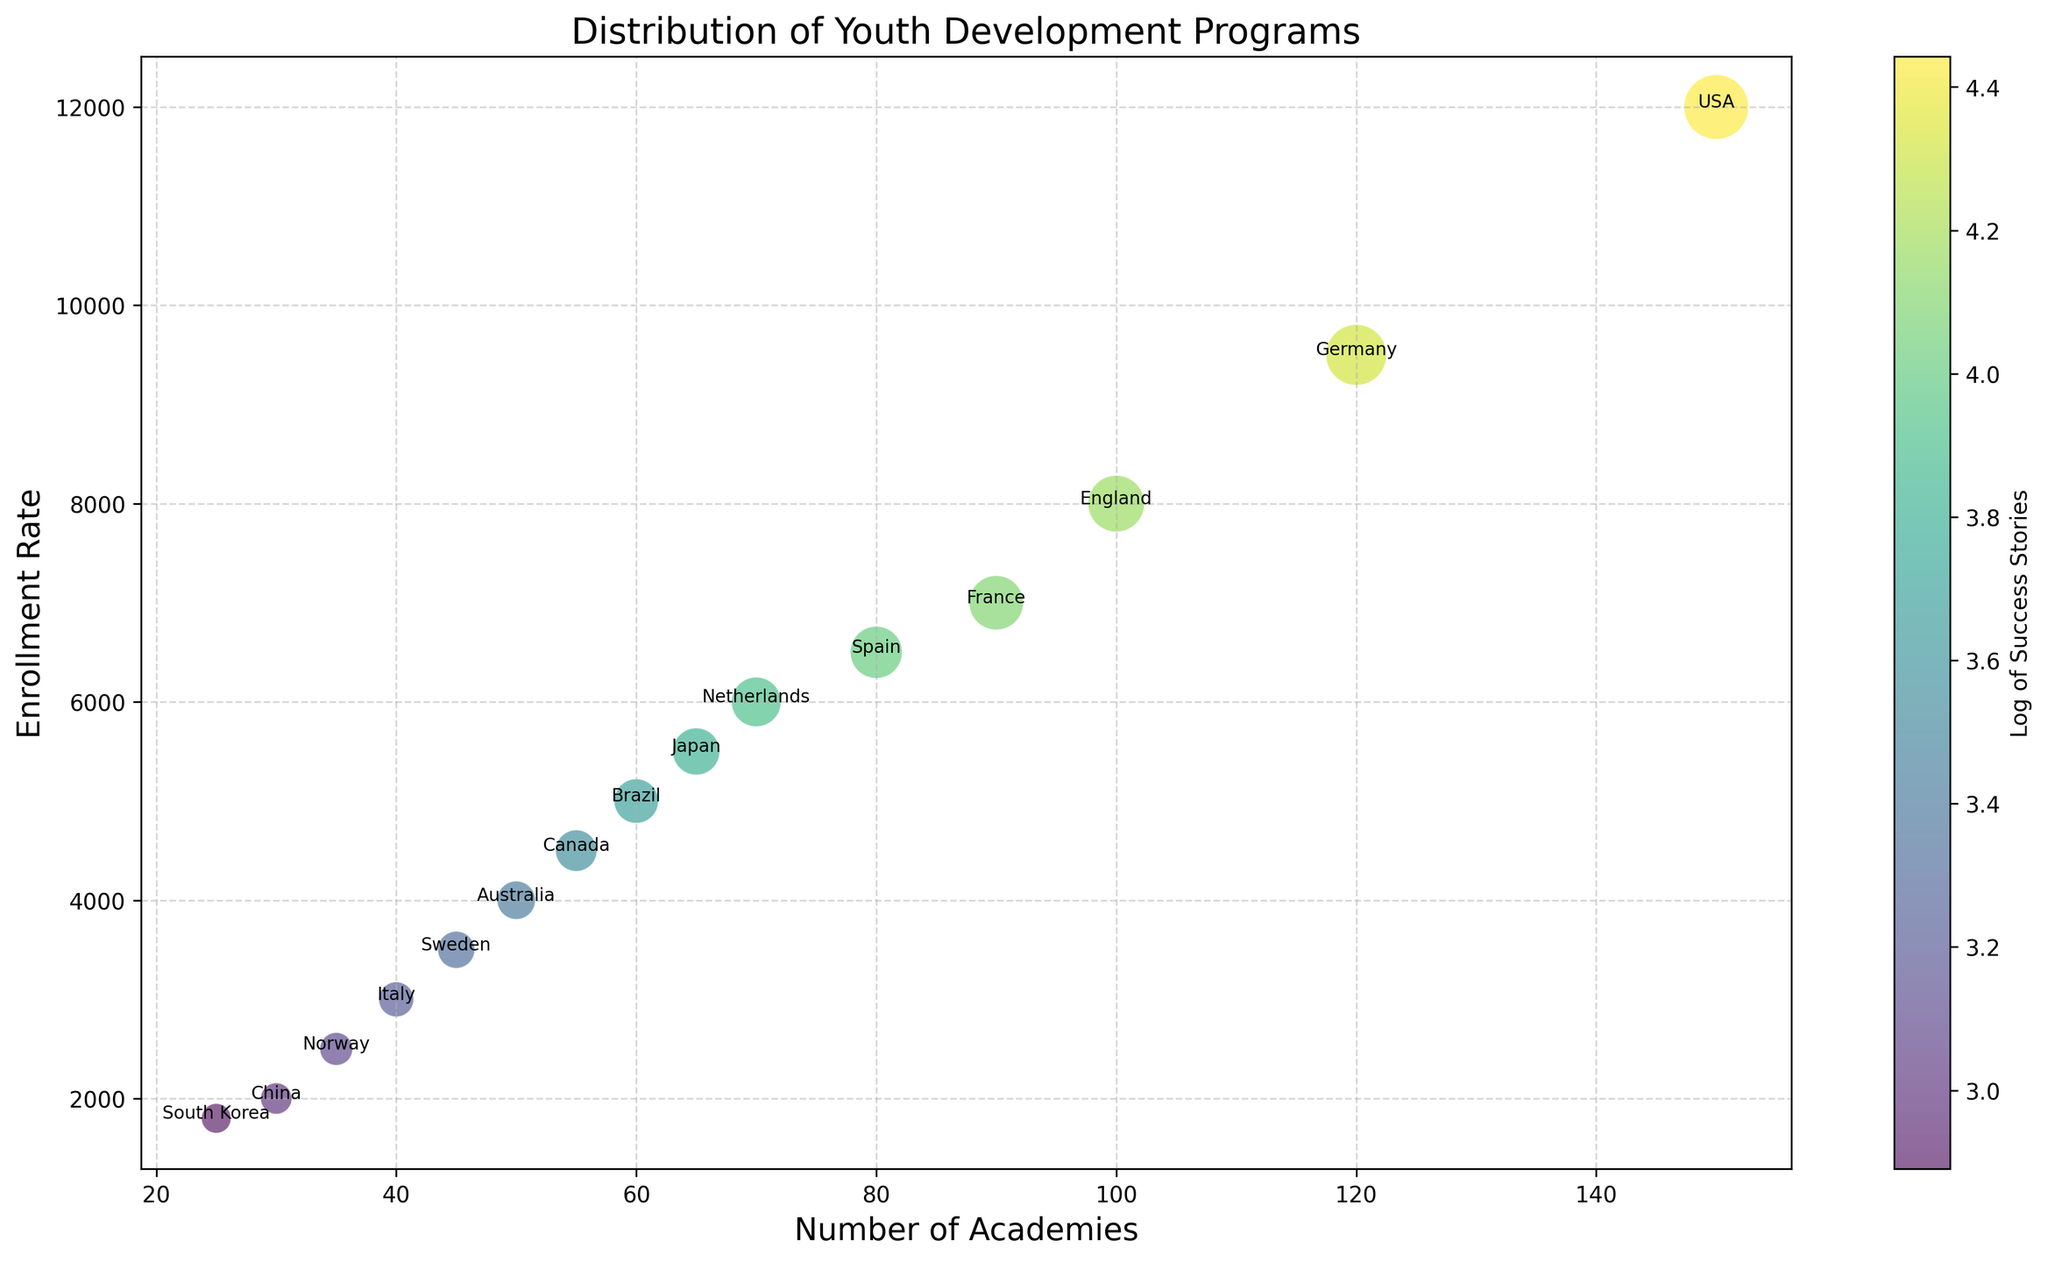What country has the highest number of youth academies? The country at the far right on the x-axis, which denotes the number of academies, is the USA.
Answer: USA How does the enrollment rate of Japan compare to Brazil? By comparing the positions of Japan and Brazil along the y-axis, we can see that Japan (5500) is higher than Brazil (5000).
Answer: Japan's enrollment rate is higher than Brazil's Which country has the largest size bubble and what does it represent? The largest bubble is for the USA. The size of the bubble represents the number of success stories.
Answer: USA has the largest number of success stories What is the log-based color indicator for Norway's bubble? The color gradient from light to dark green represents the log of success stories. Norway's bubble is relatively light green.
Answer: Low log value of success stories Compare the number of success stories between Germany and France. Germany and France can be identified by their relative positions and bubble sizes. Germany's bubble is larger than France's (75 vs. 60 success stories).
Answer: Germany has more success stories than France Which country is closer in enrollment rate to 4000 and how many academies does it have? The country closest to the 4000 mark on the y-axis is Australia, where the enrollment rate is 4000.
Answer: 50 academies How many success stories does the country with 25 academies have? The only country with 25 academies is South Korea, marked by its position along the x-axis. Its success stories can be visualized by the bubble size.
Answer: 18 success stories Is the enrollment rate for countries with more than 100 academies always higher than for those with fewer academies? We observe countries with more than 100 academies (USA, Germany) have enrollment rates higher (12000, 9500) compared to those with fewer academies.
Answer: Yes What is the difference in the number of academies between the Netherlands and Japan? The difference in the number of academies is calculated as 70 (Netherlands) - 65 (Japan).
Answer: 5 Calculate the average number of success stories for countries with at least 10000 enrollment rates. Only the USA has at least 10000 enrollment rates with 85 success stories. So, the average is 85.
Answer: 85 